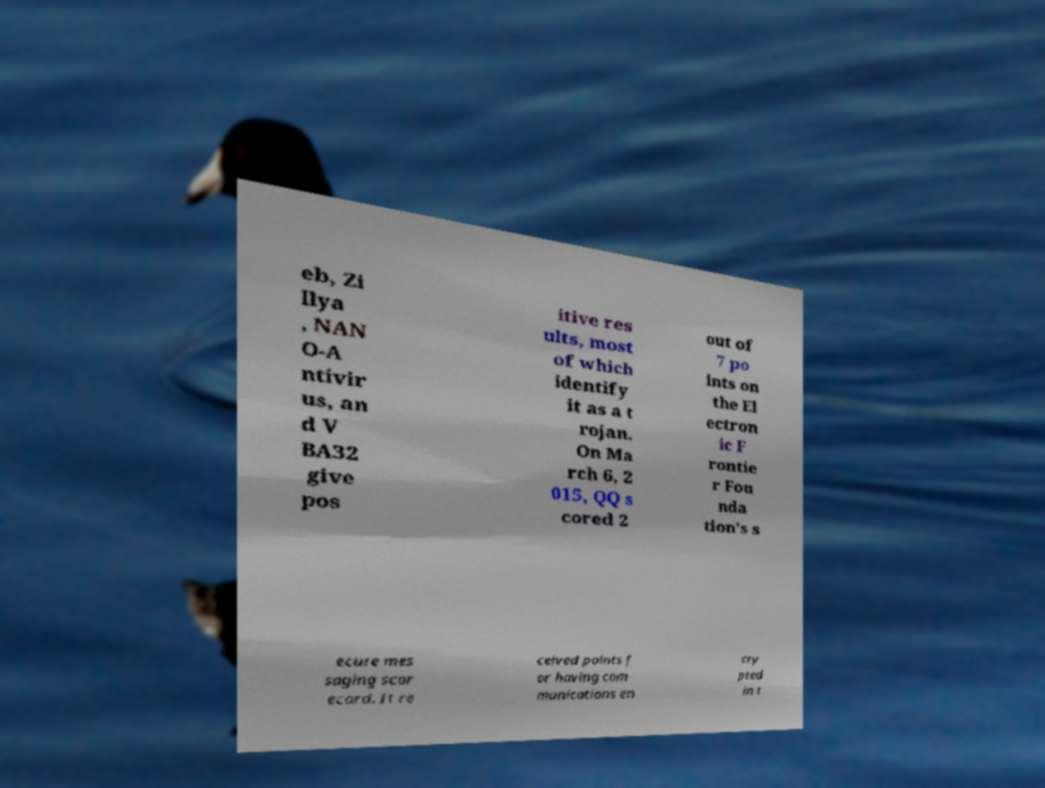Could you assist in decoding the text presented in this image and type it out clearly? eb, Zi llya , NAN O-A ntivir us, an d V BA32 give pos itive res ults, most of which identify it as a t rojan. On Ma rch 6, 2 015, QQ s cored 2 out of 7 po ints on the El ectron ic F rontie r Fou nda tion's s ecure mes saging scor ecard. It re ceived points f or having com munications en cry pted in t 